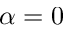Convert formula to latex. <formula><loc_0><loc_0><loc_500><loc_500>\alpha = 0</formula> 